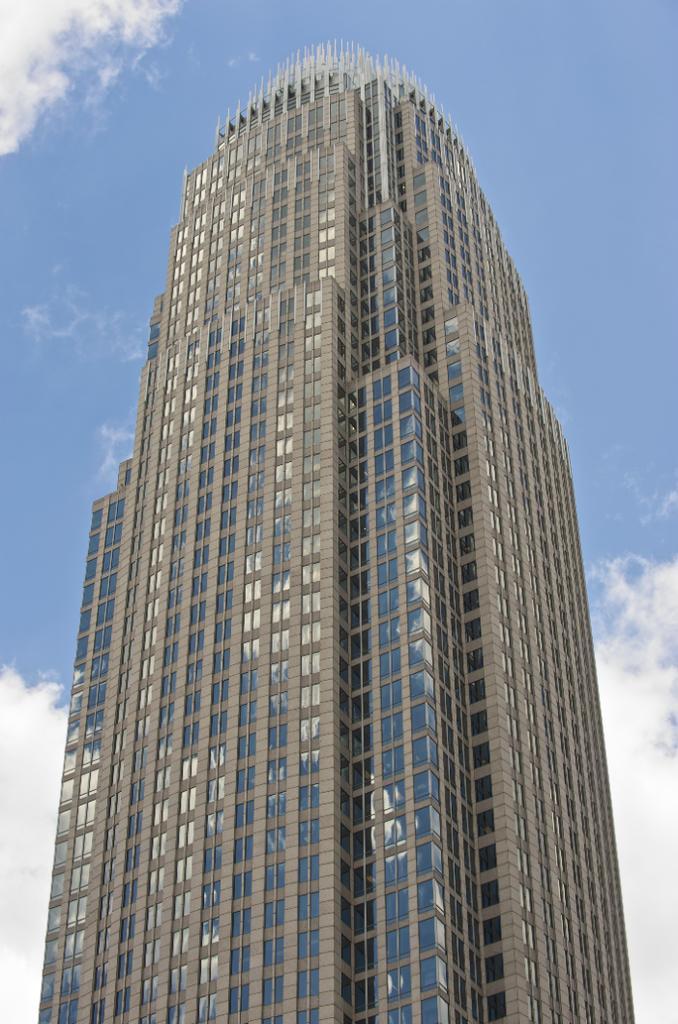In one or two sentences, can you explain what this image depicts? In the center of the image there is a building. At the top of the image there is sky. 